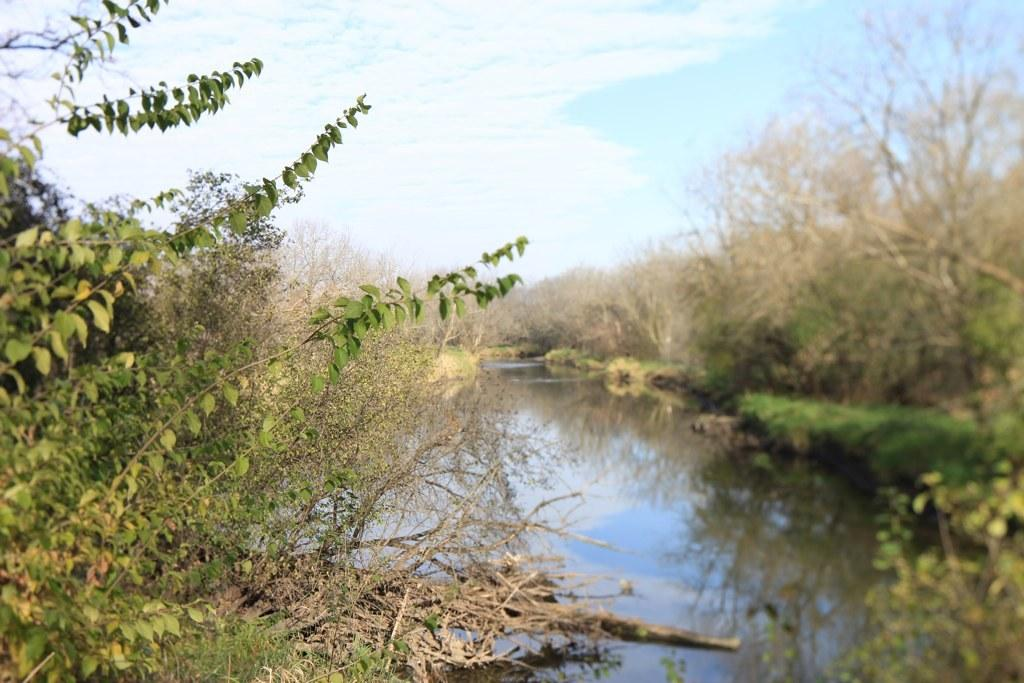What type of vegetation can be seen in the image? There are trees in the image. What colors are the trees in the image? The trees have green and brown colors. What else can be seen besides trees in the image? There is water and grass visible in the image. What is visible in the background of the image? There are trees and the sky visible in the background of the image. What type of bread can be seen in the image? There is no bread present in the image; it features trees, water, grass, and the sky. Can you tell me how many pieces of coal are visible in the image? There is no coal present in the image; it features trees, water, grass, and the sky. 